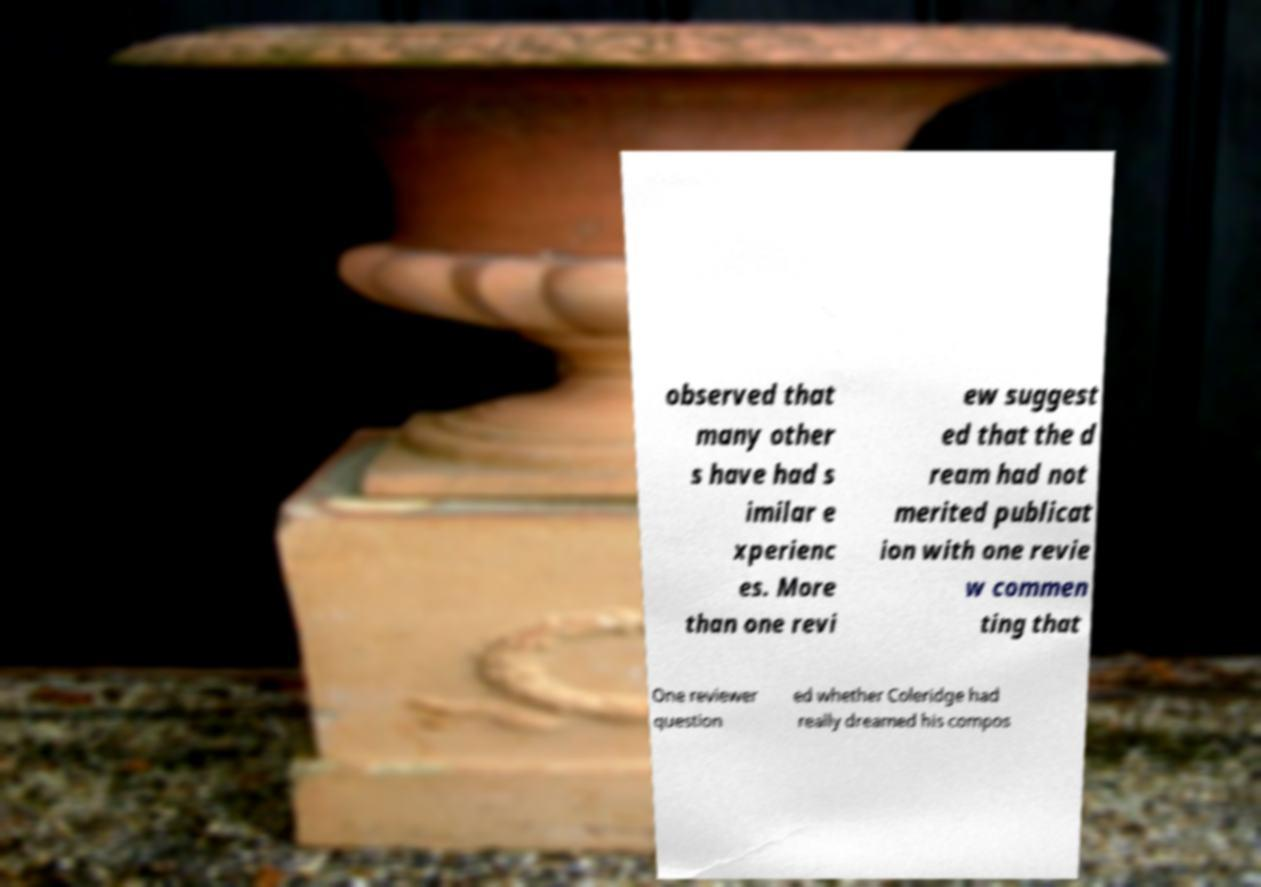There's text embedded in this image that I need extracted. Can you transcribe it verbatim? observed that many other s have had s imilar e xperienc es. More than one revi ew suggest ed that the d ream had not merited publicat ion with one revie w commen ting that One reviewer question ed whether Coleridge had really dreamed his compos 